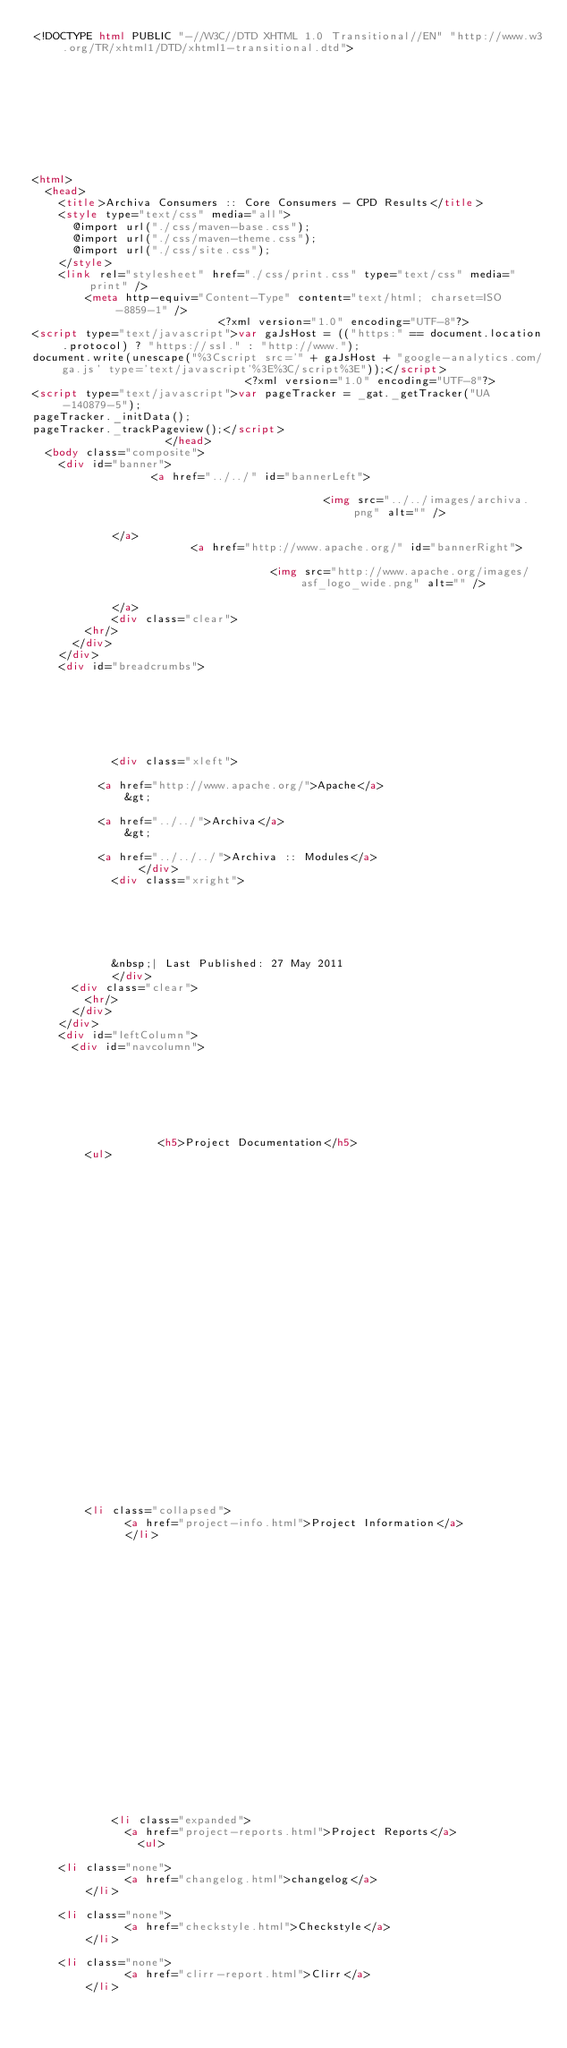<code> <loc_0><loc_0><loc_500><loc_500><_HTML_><!DOCTYPE html PUBLIC "-//W3C//DTD XHTML 1.0 Transitional//EN" "http://www.w3.org/TR/xhtml1/DTD/xhtml1-transitional.dtd">










<html>
  <head>
    <title>Archiva Consumers :: Core Consumers - CPD Results</title>
    <style type="text/css" media="all">
      @import url("./css/maven-base.css");
      @import url("./css/maven-theme.css");
      @import url("./css/site.css");
    </style>
    <link rel="stylesheet" href="./css/print.css" type="text/css" media="print" />
        <meta http-equiv="Content-Type" content="text/html; charset=ISO-8859-1" />
                            <?xml version="1.0" encoding="UTF-8"?>
<script type="text/javascript">var gaJsHost = (("https:" == document.location.protocol) ? "https://ssl." : "http://www.");
document.write(unescape("%3Cscript src='" + gaJsHost + "google-analytics.com/ga.js' type='text/javascript'%3E%3C/script%3E"));</script>
                                <?xml version="1.0" encoding="UTF-8"?>
<script type="text/javascript">var pageTracker = _gat._getTracker("UA-140879-5");
pageTracker._initData();
pageTracker._trackPageview();</script>
                    </head>
  <body class="composite">
    <div id="banner">
                  <a href="../../" id="bannerLeft">
    
                                            <img src="../../images/archiva.png" alt="" />
    
            </a>
                        <a href="http://www.apache.org/" id="bannerRight">
    
                                    <img src="http://www.apache.org/images/asf_logo_wide.png" alt="" />
    
            </a>
            <div class="clear">
        <hr/>
      </div>
    </div>
    <div id="breadcrumbs">
          
  

  
    
  
  
            <div class="xleft">
          
          <a href="http://www.apache.org/">Apache</a>
              &gt;
      
          <a href="../../">Archiva</a>
              &gt;
      
          <a href="../../../">Archiva :: Modules</a>
                </div>
            <div class="xright">      
  

  
    
  
  
            &nbsp;| Last Published: 27 May 2011
            </div>
      <div class="clear">
        <hr/>
      </div>
    </div>
    <div id="leftColumn">
      <div id="navcolumn">
           
  

  
    
  
  
                   <h5>Project Documentation</h5>
        <ul>
              
                
              
      
            
      
            
      
            
      
            
      
            
      
            
      
            
      
            
      
            
      
            
      
            
      
            
      
              
        <li class="collapsed">
              <a href="project-info.html">Project Information</a>
              </li>
              
                
              
      
            
      
            
      
            
      
            
            
            
      
            
      
            
      
            
      
            
      
              
            <li class="expanded">
              <a href="project-reports.html">Project Reports</a>
                <ul>
                  
    <li class="none">
              <a href="changelog.html">changelog</a>
        </li>
                  
    <li class="none">
              <a href="checkstyle.html">Checkstyle</a>
        </li>
                  
    <li class="none">
              <a href="clirr-report.html">Clirr</a>
        </li>
                  </code> 